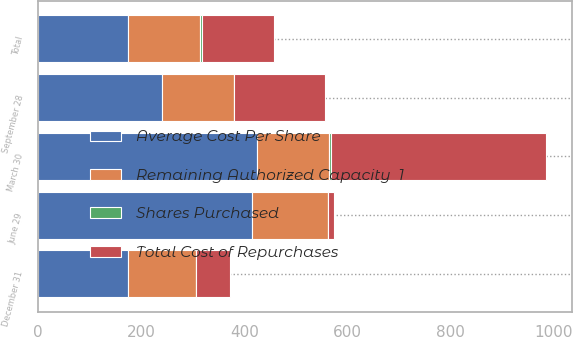<chart> <loc_0><loc_0><loc_500><loc_500><stacked_bar_chart><ecel><fcel>March 30<fcel>June 29<fcel>September 28<fcel>December 31<fcel>Total<nl><fcel>Shares Purchased<fcel>3<fcel>0.1<fcel>1.2<fcel>0.5<fcel>4.8<nl><fcel>Remaining Authorized Capacity  1<fcel>139.7<fcel>148.11<fcel>139.76<fcel>132.66<fcel>139.12<nl><fcel>Total Cost of Repurchases<fcel>419<fcel>11<fcel>175<fcel>65<fcel>139.7<nl><fcel>Average Cost Per Share<fcel>425<fcel>415<fcel>240<fcel>174<fcel>174<nl></chart> 